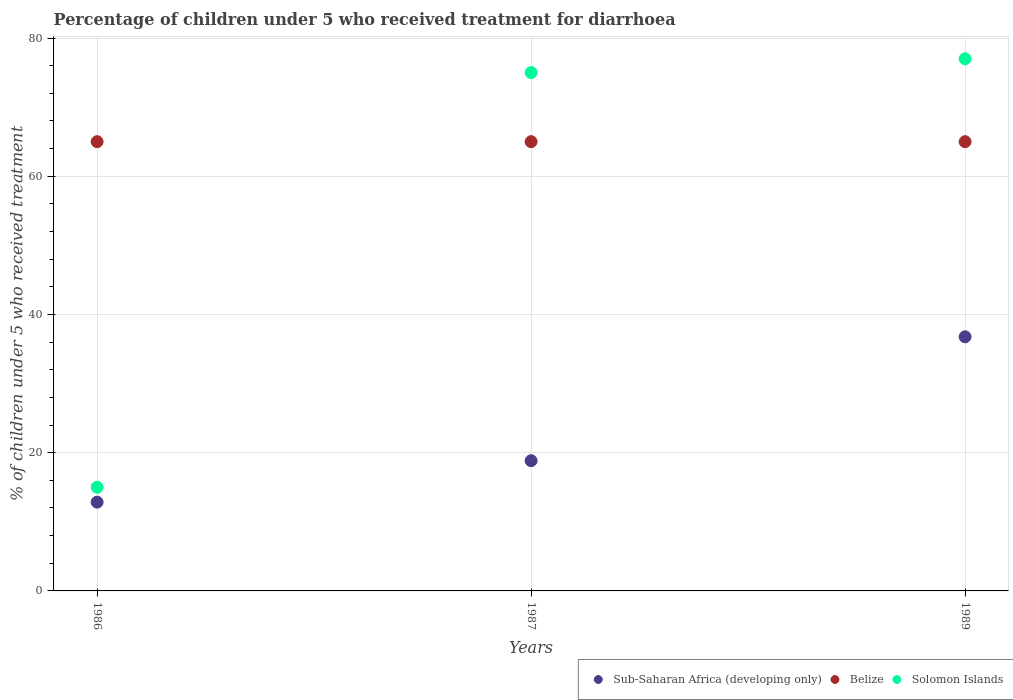Is the number of dotlines equal to the number of legend labels?
Provide a short and direct response. Yes. What is the percentage of children who received treatment for diarrhoea  in Solomon Islands in 1986?
Your response must be concise. 15. Across all years, what is the minimum percentage of children who received treatment for diarrhoea  in Sub-Saharan Africa (developing only)?
Make the answer very short. 12.84. In which year was the percentage of children who received treatment for diarrhoea  in Sub-Saharan Africa (developing only) maximum?
Your answer should be compact. 1989. What is the total percentage of children who received treatment for diarrhoea  in Belize in the graph?
Your answer should be very brief. 195. What is the difference between the percentage of children who received treatment for diarrhoea  in Sub-Saharan Africa (developing only) in 1986 and that in 1989?
Ensure brevity in your answer.  -23.92. What is the difference between the percentage of children who received treatment for diarrhoea  in Belize in 1989 and the percentage of children who received treatment for diarrhoea  in Solomon Islands in 1987?
Your response must be concise. -10. What is the average percentage of children who received treatment for diarrhoea  in Sub-Saharan Africa (developing only) per year?
Offer a terse response. 22.82. In how many years, is the percentage of children who received treatment for diarrhoea  in Belize greater than 76 %?
Make the answer very short. 0. What is the ratio of the percentage of children who received treatment for diarrhoea  in Sub-Saharan Africa (developing only) in 1986 to that in 1987?
Make the answer very short. 0.68. Is the percentage of children who received treatment for diarrhoea  in Sub-Saharan Africa (developing only) in 1986 less than that in 1987?
Your response must be concise. Yes. Is the difference between the percentage of children who received treatment for diarrhoea  in Belize in 1986 and 1987 greater than the difference between the percentage of children who received treatment for diarrhoea  in Solomon Islands in 1986 and 1987?
Offer a terse response. Yes. What is the difference between the highest and the second highest percentage of children who received treatment for diarrhoea  in Sub-Saharan Africa (developing only)?
Provide a succinct answer. 17.92. What is the difference between the highest and the lowest percentage of children who received treatment for diarrhoea  in Sub-Saharan Africa (developing only)?
Offer a very short reply. 23.92. In how many years, is the percentage of children who received treatment for diarrhoea  in Solomon Islands greater than the average percentage of children who received treatment for diarrhoea  in Solomon Islands taken over all years?
Offer a very short reply. 2. Is the percentage of children who received treatment for diarrhoea  in Sub-Saharan Africa (developing only) strictly less than the percentage of children who received treatment for diarrhoea  in Solomon Islands over the years?
Keep it short and to the point. Yes. How many dotlines are there?
Your answer should be very brief. 3. How many years are there in the graph?
Give a very brief answer. 3. What is the difference between two consecutive major ticks on the Y-axis?
Offer a terse response. 20. Are the values on the major ticks of Y-axis written in scientific E-notation?
Provide a short and direct response. No. Does the graph contain any zero values?
Give a very brief answer. No. Does the graph contain grids?
Give a very brief answer. Yes. What is the title of the graph?
Keep it short and to the point. Percentage of children under 5 who received treatment for diarrhoea. What is the label or title of the X-axis?
Your answer should be very brief. Years. What is the label or title of the Y-axis?
Offer a terse response. % of children under 5 who received treatment. What is the % of children under 5 who received treatment of Sub-Saharan Africa (developing only) in 1986?
Your answer should be compact. 12.84. What is the % of children under 5 who received treatment of Belize in 1986?
Ensure brevity in your answer.  65. What is the % of children under 5 who received treatment of Solomon Islands in 1986?
Make the answer very short. 15. What is the % of children under 5 who received treatment in Sub-Saharan Africa (developing only) in 1987?
Provide a succinct answer. 18.84. What is the % of children under 5 who received treatment in Sub-Saharan Africa (developing only) in 1989?
Make the answer very short. 36.77. What is the % of children under 5 who received treatment in Belize in 1989?
Give a very brief answer. 65. Across all years, what is the maximum % of children under 5 who received treatment of Sub-Saharan Africa (developing only)?
Your answer should be very brief. 36.77. Across all years, what is the maximum % of children under 5 who received treatment in Solomon Islands?
Provide a short and direct response. 77. Across all years, what is the minimum % of children under 5 who received treatment in Sub-Saharan Africa (developing only)?
Your answer should be very brief. 12.84. What is the total % of children under 5 who received treatment in Sub-Saharan Africa (developing only) in the graph?
Provide a succinct answer. 68.46. What is the total % of children under 5 who received treatment in Belize in the graph?
Offer a very short reply. 195. What is the total % of children under 5 who received treatment in Solomon Islands in the graph?
Keep it short and to the point. 167. What is the difference between the % of children under 5 who received treatment of Sub-Saharan Africa (developing only) in 1986 and that in 1987?
Keep it short and to the point. -6. What is the difference between the % of children under 5 who received treatment of Belize in 1986 and that in 1987?
Your answer should be compact. 0. What is the difference between the % of children under 5 who received treatment of Solomon Islands in 1986 and that in 1987?
Provide a succinct answer. -60. What is the difference between the % of children under 5 who received treatment in Sub-Saharan Africa (developing only) in 1986 and that in 1989?
Give a very brief answer. -23.92. What is the difference between the % of children under 5 who received treatment in Solomon Islands in 1986 and that in 1989?
Provide a succinct answer. -62. What is the difference between the % of children under 5 who received treatment of Sub-Saharan Africa (developing only) in 1987 and that in 1989?
Ensure brevity in your answer.  -17.92. What is the difference between the % of children under 5 who received treatment in Belize in 1987 and that in 1989?
Offer a terse response. 0. What is the difference between the % of children under 5 who received treatment of Sub-Saharan Africa (developing only) in 1986 and the % of children under 5 who received treatment of Belize in 1987?
Provide a succinct answer. -52.16. What is the difference between the % of children under 5 who received treatment in Sub-Saharan Africa (developing only) in 1986 and the % of children under 5 who received treatment in Solomon Islands in 1987?
Offer a terse response. -62.16. What is the difference between the % of children under 5 who received treatment of Sub-Saharan Africa (developing only) in 1986 and the % of children under 5 who received treatment of Belize in 1989?
Your answer should be compact. -52.16. What is the difference between the % of children under 5 who received treatment of Sub-Saharan Africa (developing only) in 1986 and the % of children under 5 who received treatment of Solomon Islands in 1989?
Your answer should be very brief. -64.16. What is the difference between the % of children under 5 who received treatment in Belize in 1986 and the % of children under 5 who received treatment in Solomon Islands in 1989?
Your response must be concise. -12. What is the difference between the % of children under 5 who received treatment in Sub-Saharan Africa (developing only) in 1987 and the % of children under 5 who received treatment in Belize in 1989?
Your answer should be very brief. -46.16. What is the difference between the % of children under 5 who received treatment in Sub-Saharan Africa (developing only) in 1987 and the % of children under 5 who received treatment in Solomon Islands in 1989?
Ensure brevity in your answer.  -58.16. What is the average % of children under 5 who received treatment of Sub-Saharan Africa (developing only) per year?
Keep it short and to the point. 22.82. What is the average % of children under 5 who received treatment in Belize per year?
Provide a succinct answer. 65. What is the average % of children under 5 who received treatment in Solomon Islands per year?
Offer a terse response. 55.67. In the year 1986, what is the difference between the % of children under 5 who received treatment in Sub-Saharan Africa (developing only) and % of children under 5 who received treatment in Belize?
Keep it short and to the point. -52.16. In the year 1986, what is the difference between the % of children under 5 who received treatment in Sub-Saharan Africa (developing only) and % of children under 5 who received treatment in Solomon Islands?
Your response must be concise. -2.16. In the year 1986, what is the difference between the % of children under 5 who received treatment of Belize and % of children under 5 who received treatment of Solomon Islands?
Keep it short and to the point. 50. In the year 1987, what is the difference between the % of children under 5 who received treatment of Sub-Saharan Africa (developing only) and % of children under 5 who received treatment of Belize?
Provide a succinct answer. -46.16. In the year 1987, what is the difference between the % of children under 5 who received treatment in Sub-Saharan Africa (developing only) and % of children under 5 who received treatment in Solomon Islands?
Make the answer very short. -56.16. In the year 1989, what is the difference between the % of children under 5 who received treatment in Sub-Saharan Africa (developing only) and % of children under 5 who received treatment in Belize?
Offer a terse response. -28.23. In the year 1989, what is the difference between the % of children under 5 who received treatment of Sub-Saharan Africa (developing only) and % of children under 5 who received treatment of Solomon Islands?
Your response must be concise. -40.23. What is the ratio of the % of children under 5 who received treatment of Sub-Saharan Africa (developing only) in 1986 to that in 1987?
Give a very brief answer. 0.68. What is the ratio of the % of children under 5 who received treatment of Belize in 1986 to that in 1987?
Give a very brief answer. 1. What is the ratio of the % of children under 5 who received treatment of Solomon Islands in 1986 to that in 1987?
Your response must be concise. 0.2. What is the ratio of the % of children under 5 who received treatment in Sub-Saharan Africa (developing only) in 1986 to that in 1989?
Your answer should be very brief. 0.35. What is the ratio of the % of children under 5 who received treatment in Belize in 1986 to that in 1989?
Provide a succinct answer. 1. What is the ratio of the % of children under 5 who received treatment in Solomon Islands in 1986 to that in 1989?
Ensure brevity in your answer.  0.19. What is the ratio of the % of children under 5 who received treatment in Sub-Saharan Africa (developing only) in 1987 to that in 1989?
Provide a short and direct response. 0.51. What is the ratio of the % of children under 5 who received treatment in Belize in 1987 to that in 1989?
Make the answer very short. 1. What is the ratio of the % of children under 5 who received treatment in Solomon Islands in 1987 to that in 1989?
Keep it short and to the point. 0.97. What is the difference between the highest and the second highest % of children under 5 who received treatment in Sub-Saharan Africa (developing only)?
Provide a succinct answer. 17.92. What is the difference between the highest and the second highest % of children under 5 who received treatment in Solomon Islands?
Provide a short and direct response. 2. What is the difference between the highest and the lowest % of children under 5 who received treatment of Sub-Saharan Africa (developing only)?
Give a very brief answer. 23.92. 